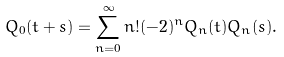<formula> <loc_0><loc_0><loc_500><loc_500>Q _ { 0 } ( t + s ) = \sum _ { n = 0 } ^ { \infty } n ! ( - 2 ) ^ { n } Q _ { n } ( t ) Q _ { n } ( s ) .</formula> 